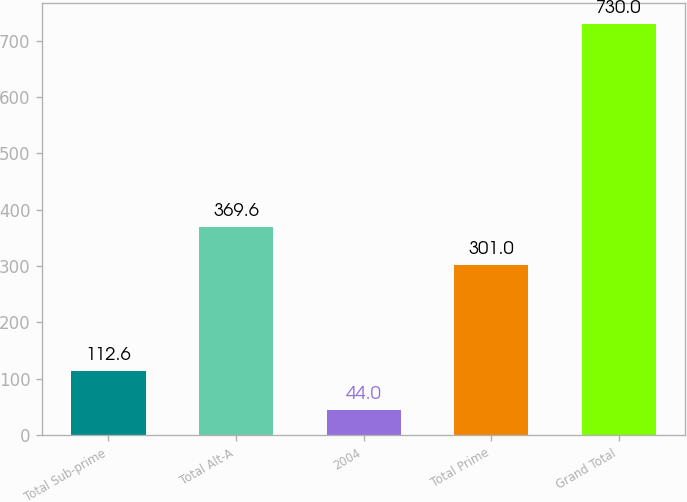<chart> <loc_0><loc_0><loc_500><loc_500><bar_chart><fcel>Total Sub-prime<fcel>Total Alt-A<fcel>2004<fcel>Total Prime<fcel>Grand Total<nl><fcel>112.6<fcel>369.6<fcel>44<fcel>301<fcel>730<nl></chart> 